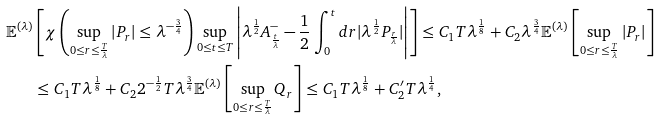<formula> <loc_0><loc_0><loc_500><loc_500>\mathbb { E } ^ { ( \lambda ) } & \left [ \chi \left ( \sup _ { 0 \leq r \leq \frac { T } { \lambda } } | P _ { r } | \leq \lambda ^ { - \frac { 3 } { 4 } } \right ) \sup _ { 0 \leq t \leq T } \left | \lambda ^ { \frac { 1 } { 2 } } A _ { \frac { t } { \lambda } } ^ { - } - \frac { 1 } { 2 } \int _ { 0 } ^ { t } d r | \lambda ^ { \frac { 1 } { 2 } } P _ { \frac { r } { \lambda } } | \right | \right ] \leq C _ { 1 } T \lambda ^ { \frac { 1 } { 8 } } + C _ { 2 } \lambda ^ { \frac { 3 } { 4 } } \mathbb { E } ^ { ( \lambda ) } \left [ \sup _ { 0 \leq r \leq \frac { T } { \lambda } } \left | P _ { r } \right | \right ] \\ & \leq C _ { 1 } T \lambda ^ { \frac { 1 } { 8 } } + C _ { 2 } 2 ^ { - \frac { 1 } { 2 } } T \lambda ^ { \frac { 3 } { 4 } } \mathbb { E } ^ { ( \lambda ) } \left [ \sup _ { 0 \leq r \leq \frac { T } { \lambda } } Q _ { r } \right ] \leq C _ { 1 } T \lambda ^ { \frac { 1 } { 8 } } + C _ { 2 } ^ { \prime } T \lambda ^ { \frac { 1 } { 4 } } ,</formula> 